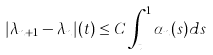Convert formula to latex. <formula><loc_0><loc_0><loc_500><loc_500>| \lambda _ { n + 1 } - \lambda _ { n } | ( t ) \leq C \int _ { t } ^ { 1 } \alpha _ { n } ( s ) d s</formula> 